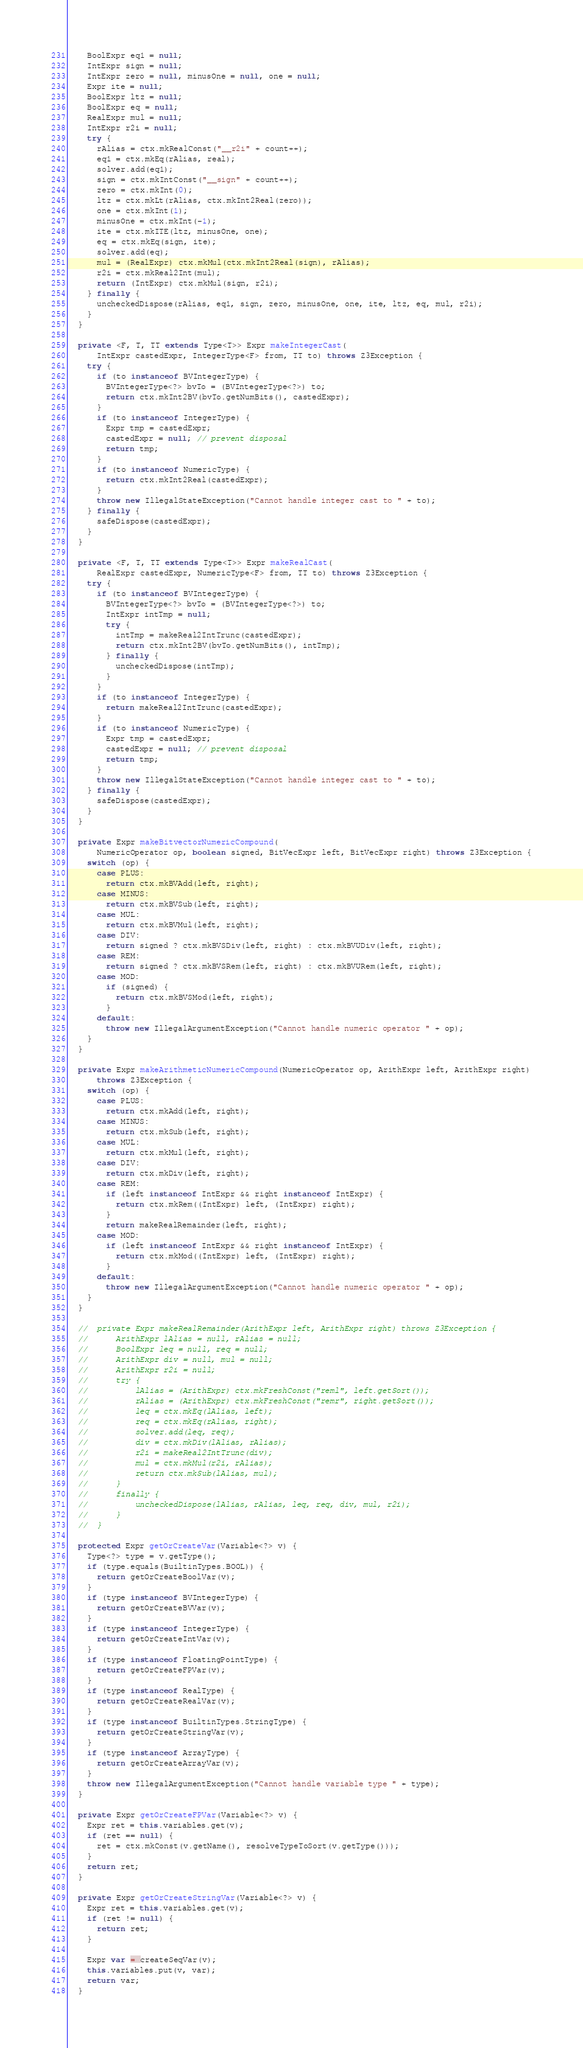Convert code to text. <code><loc_0><loc_0><loc_500><loc_500><_Java_>    BoolExpr eq1 = null;
    IntExpr sign = null;
    IntExpr zero = null, minusOne = null, one = null;
    Expr ite = null;
    BoolExpr ltz = null;
    BoolExpr eq = null;
    RealExpr mul = null;
    IntExpr r2i = null;
    try {
      rAlias = ctx.mkRealConst("__r2i" + count++);
      eq1 = ctx.mkEq(rAlias, real);
      solver.add(eq1);
      sign = ctx.mkIntConst("__sign" + count++);
      zero = ctx.mkInt(0);
      ltz = ctx.mkLt(rAlias, ctx.mkInt2Real(zero));
      one = ctx.mkInt(1);
      minusOne = ctx.mkInt(-1);
      ite = ctx.mkITE(ltz, minusOne, one);
      eq = ctx.mkEq(sign, ite);
      solver.add(eq);
      mul = (RealExpr) ctx.mkMul(ctx.mkInt2Real(sign), rAlias);
      r2i = ctx.mkReal2Int(mul);
      return (IntExpr) ctx.mkMul(sign, r2i);
    } finally {
      uncheckedDispose(rAlias, eq1, sign, zero, minusOne, one, ite, ltz, eq, mul, r2i);
    }
  }

  private <F, T, TT extends Type<T>> Expr makeIntegerCast(
      IntExpr castedExpr, IntegerType<F> from, TT to) throws Z3Exception {
    try {
      if (to instanceof BVIntegerType) {
        BVIntegerType<?> bvTo = (BVIntegerType<?>) to;
        return ctx.mkInt2BV(bvTo.getNumBits(), castedExpr);
      }
      if (to instanceof IntegerType) {
        Expr tmp = castedExpr;
        castedExpr = null; // prevent disposal
        return tmp;
      }
      if (to instanceof NumericType) {
        return ctx.mkInt2Real(castedExpr);
      }
      throw new IllegalStateException("Cannot handle integer cast to " + to);
    } finally {
      safeDispose(castedExpr);
    }
  }

  private <F, T, TT extends Type<T>> Expr makeRealCast(
      RealExpr castedExpr, NumericType<F> from, TT to) throws Z3Exception {
    try {
      if (to instanceof BVIntegerType) {
        BVIntegerType<?> bvTo = (BVIntegerType<?>) to;
        IntExpr intTmp = null;
        try {
          intTmp = makeReal2IntTrunc(castedExpr);
          return ctx.mkInt2BV(bvTo.getNumBits(), intTmp);
        } finally {
          uncheckedDispose(intTmp);
        }
      }
      if (to instanceof IntegerType) {
        return makeReal2IntTrunc(castedExpr);
      }
      if (to instanceof NumericType) {
        Expr tmp = castedExpr;
        castedExpr = null; // prevent disposal
        return tmp;
      }
      throw new IllegalStateException("Cannot handle integer cast to " + to);
    } finally {
      safeDispose(castedExpr);
    }
  }

  private Expr makeBitvectorNumericCompound(
      NumericOperator op, boolean signed, BitVecExpr left, BitVecExpr right) throws Z3Exception {
    switch (op) {
      case PLUS:
        return ctx.mkBVAdd(left, right);
      case MINUS:
        return ctx.mkBVSub(left, right);
      case MUL:
        return ctx.mkBVMul(left, right);
      case DIV:
        return signed ? ctx.mkBVSDiv(left, right) : ctx.mkBVUDiv(left, right);
      case REM:
        return signed ? ctx.mkBVSRem(left, right) : ctx.mkBVURem(left, right);
      case MOD:
        if (signed) {
          return ctx.mkBVSMod(left, right);
        }
      default:
        throw new IllegalArgumentException("Cannot handle numeric operator " + op);
    }
  }

  private Expr makeArithmeticNumericCompound(NumericOperator op, ArithExpr left, ArithExpr right)
      throws Z3Exception {
    switch (op) {
      case PLUS:
        return ctx.mkAdd(left, right);
      case MINUS:
        return ctx.mkSub(left, right);
      case MUL:
        return ctx.mkMul(left, right);
      case DIV:
        return ctx.mkDiv(left, right);
      case REM:
        if (left instanceof IntExpr && right instanceof IntExpr) {
          return ctx.mkRem((IntExpr) left, (IntExpr) right);
        }
        return makeRealRemainder(left, right);
      case MOD:
        if (left instanceof IntExpr && right instanceof IntExpr) {
          return ctx.mkMod((IntExpr) left, (IntExpr) right);
        }
      default:
        throw new IllegalArgumentException("Cannot handle numeric operator " + op);
    }
  }

  //	private Expr makeRealRemainder(ArithExpr left, ArithExpr right) throws Z3Exception {
  //		ArithExpr lAlias = null, rAlias = null;
  //		BoolExpr leq = null, req = null;
  //		ArithExpr div = null, mul = null;
  //		ArithExpr r2i = null;
  //		try {
  //			lAlias = (ArithExpr) ctx.mkFreshConst("reml", left.getSort());
  //			rAlias = (ArithExpr) ctx.mkFreshConst("remr", right.getSort());
  //			leq = ctx.mkEq(lAlias, left);
  //			req = ctx.mkEq(rAlias, right);
  //			solver.add(leq, req);
  //			div = ctx.mkDiv(lAlias, rAlias);
  //			r2i = makeReal2IntTrunc(div);
  //			mul = ctx.mkMul(r2i, rAlias);
  //			return ctx.mkSub(lAlias, mul);
  //		}
  //		finally {
  //			uncheckedDispose(lAlias, rAlias, leq, req, div, mul, r2i);
  //		}
  //	}

  protected Expr getOrCreateVar(Variable<?> v) {
    Type<?> type = v.getType();
    if (type.equals(BuiltinTypes.BOOL)) {
      return getOrCreateBoolVar(v);
    }
    if (type instanceof BVIntegerType) {
      return getOrCreateBVVar(v);
    }
    if (type instanceof IntegerType) {
      return getOrCreateIntVar(v);
    }
    if (type instanceof FloatingPointType) {
      return getOrCreateFPVar(v);
    }
    if (type instanceof RealType) {
      return getOrCreateRealVar(v);
    }
    if (type instanceof BuiltinTypes.StringType) {
      return getOrCreateStringVar(v);
    }
    if (type instanceof ArrayType) {
      return getOrCreateArrayVar(v);
    }
    throw new IllegalArgumentException("Cannot handle variable type " + type);
  }

  private Expr getOrCreateFPVar(Variable<?> v) {
    Expr ret = this.variables.get(v);
    if (ret == null) {
      ret = ctx.mkConst(v.getName(), resolveTypeToSort(v.getType()));
    }
    return ret;
  }

  private Expr getOrCreateStringVar(Variable<?> v) {
    Expr ret = this.variables.get(v);
    if (ret != null) {
      return ret;
    }

    Expr var = createSeqVar(v);
    this.variables.put(v, var);
    return var;
  }
</code> 